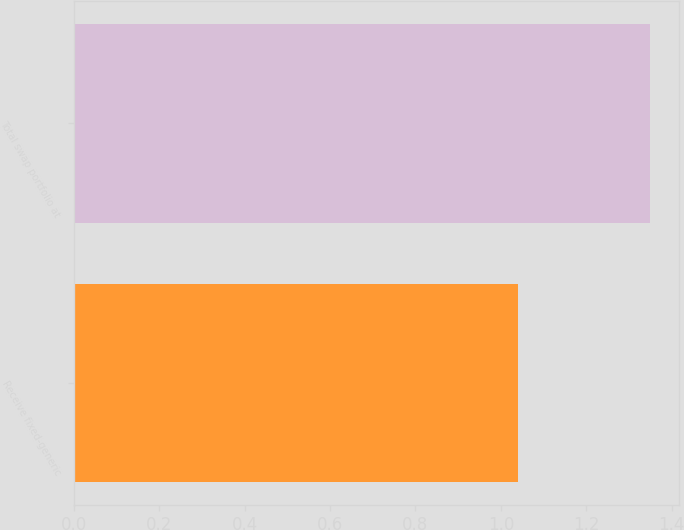Convert chart to OTSL. <chart><loc_0><loc_0><loc_500><loc_500><bar_chart><fcel>Receive fixed-generic<fcel>Total swap portfolio at<nl><fcel>1.04<fcel>1.35<nl></chart> 